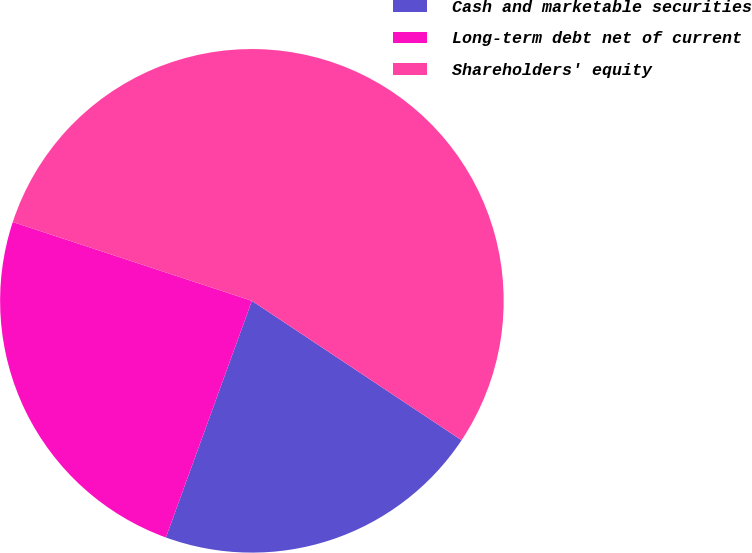Convert chart to OTSL. <chart><loc_0><loc_0><loc_500><loc_500><pie_chart><fcel>Cash and marketable securities<fcel>Long-term debt net of current<fcel>Shareholders' equity<nl><fcel>21.21%<fcel>24.52%<fcel>54.27%<nl></chart> 